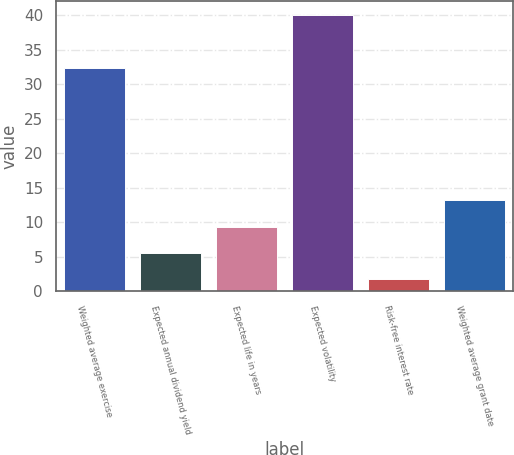Convert chart. <chart><loc_0><loc_0><loc_500><loc_500><bar_chart><fcel>Weighted average exercise<fcel>Expected annual dividend yield<fcel>Expected life in years<fcel>Expected volatility<fcel>Risk-free interest rate<fcel>Weighted average grant date<nl><fcel>32.3<fcel>5.53<fcel>9.36<fcel>40<fcel>1.7<fcel>13.19<nl></chart> 